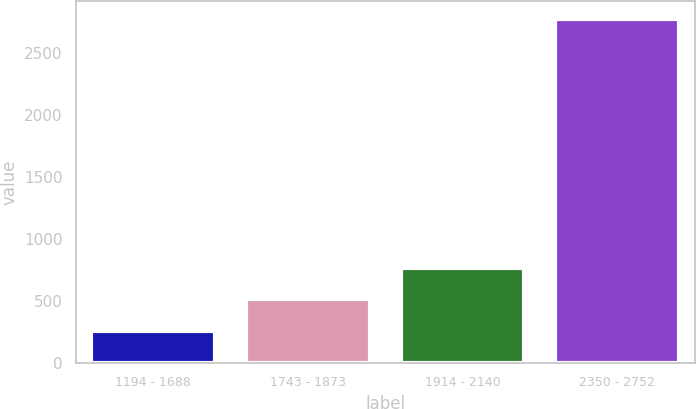Convert chart to OTSL. <chart><loc_0><loc_0><loc_500><loc_500><bar_chart><fcel>1194 - 1688<fcel>1743 - 1873<fcel>1914 - 2140<fcel>2350 - 2752<nl><fcel>260<fcel>511.8<fcel>763.6<fcel>2778<nl></chart> 